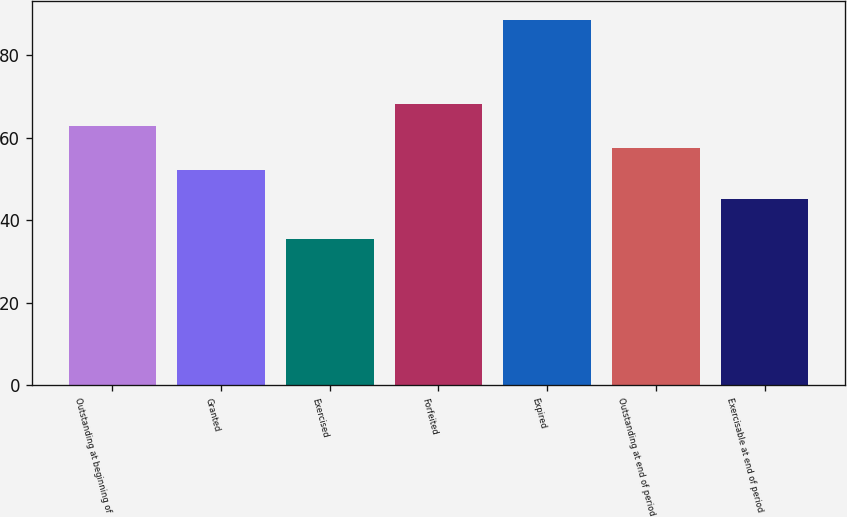Convert chart. <chart><loc_0><loc_0><loc_500><loc_500><bar_chart><fcel>Outstanding at beginning of<fcel>Granted<fcel>Exercised<fcel>Forfeited<fcel>Expired<fcel>Outstanding at end of period<fcel>Exercisable at end of period<nl><fcel>62.79<fcel>52.13<fcel>35.37<fcel>68.12<fcel>88.65<fcel>57.46<fcel>45.14<nl></chart> 